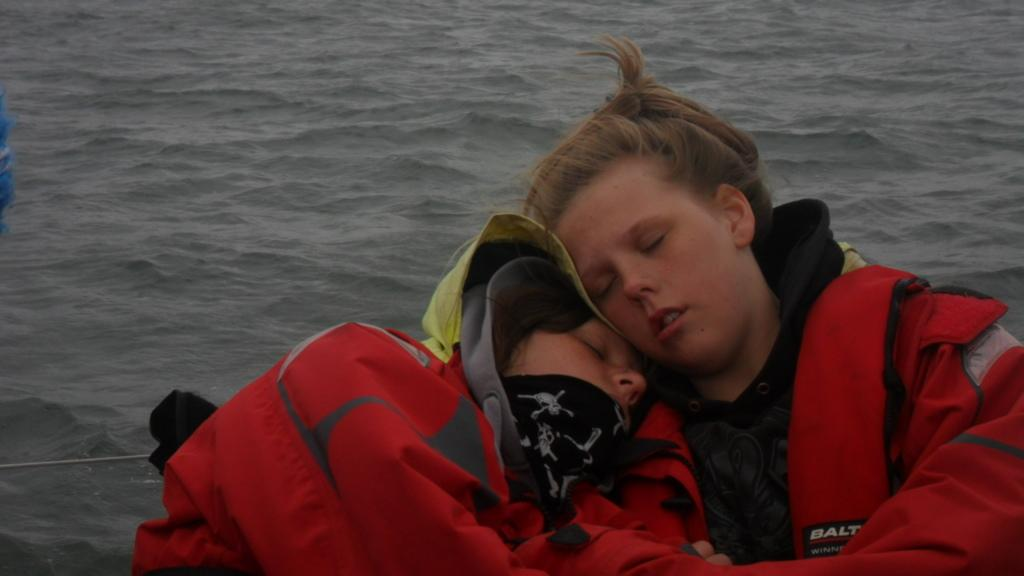How many people are in the image? There are two people in the image. What are the two people doing in the image? The two people are lying on each other in the image. Where are the two people located in the image? They are in a boat in the image. What can be seen in the background of the image? There is water visible in the image. What type of vegetable is growing on the playground in the image? There is no vegetable or playground present in the image; it features two people lying on each other in a boat on water. 